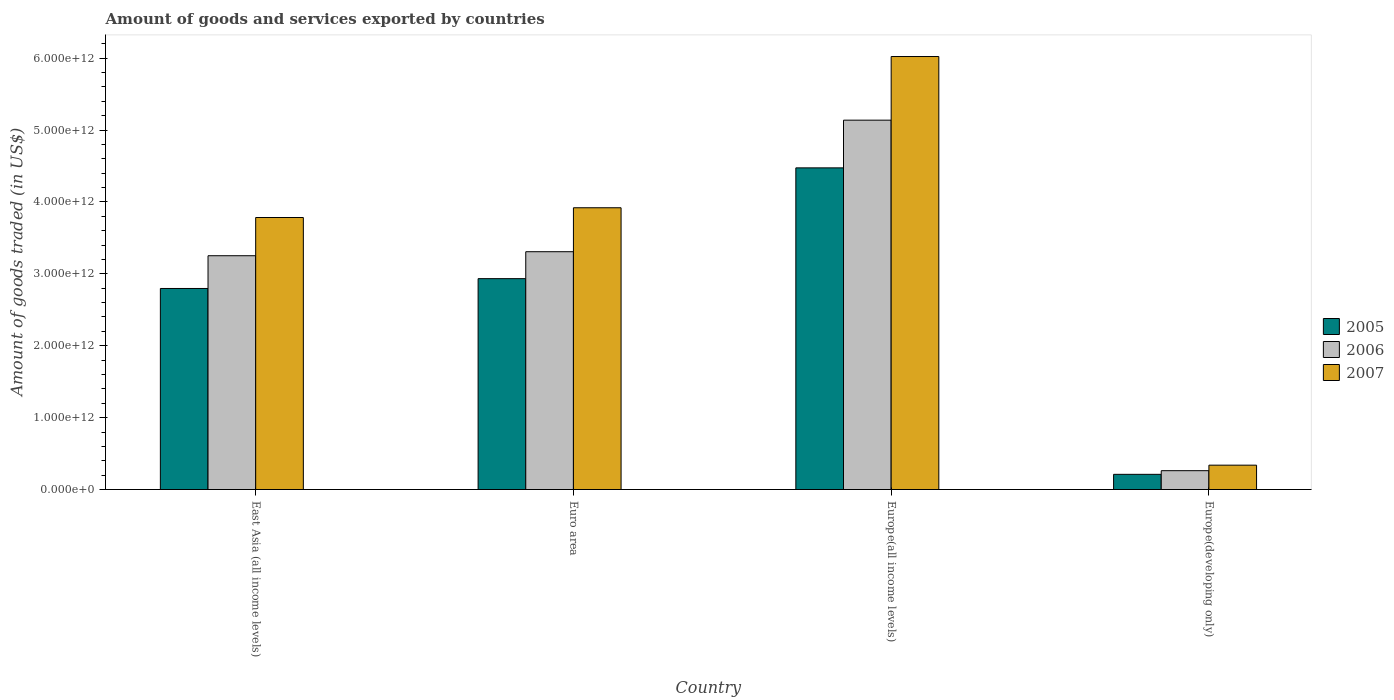How many groups of bars are there?
Your answer should be very brief. 4. How many bars are there on the 1st tick from the left?
Your answer should be compact. 3. How many bars are there on the 3rd tick from the right?
Provide a short and direct response. 3. What is the label of the 3rd group of bars from the left?
Ensure brevity in your answer.  Europe(all income levels). In how many cases, is the number of bars for a given country not equal to the number of legend labels?
Your answer should be very brief. 0. What is the total amount of goods and services exported in 2007 in Europe(developing only)?
Make the answer very short. 3.39e+11. Across all countries, what is the maximum total amount of goods and services exported in 2006?
Give a very brief answer. 5.14e+12. Across all countries, what is the minimum total amount of goods and services exported in 2007?
Offer a terse response. 3.39e+11. In which country was the total amount of goods and services exported in 2006 maximum?
Your answer should be very brief. Europe(all income levels). In which country was the total amount of goods and services exported in 2006 minimum?
Your answer should be very brief. Europe(developing only). What is the total total amount of goods and services exported in 2007 in the graph?
Provide a succinct answer. 1.41e+13. What is the difference between the total amount of goods and services exported in 2006 in Euro area and that in Europe(developing only)?
Keep it short and to the point. 3.05e+12. What is the difference between the total amount of goods and services exported in 2005 in East Asia (all income levels) and the total amount of goods and services exported in 2006 in Europe(all income levels)?
Keep it short and to the point. -2.34e+12. What is the average total amount of goods and services exported in 2005 per country?
Your response must be concise. 2.60e+12. What is the difference between the total amount of goods and services exported of/in 2005 and total amount of goods and services exported of/in 2006 in East Asia (all income levels)?
Give a very brief answer. -4.55e+11. In how many countries, is the total amount of goods and services exported in 2006 greater than 800000000000 US$?
Ensure brevity in your answer.  3. What is the ratio of the total amount of goods and services exported in 2005 in Europe(all income levels) to that in Europe(developing only)?
Offer a very short reply. 21.19. Is the difference between the total amount of goods and services exported in 2005 in Euro area and Europe(all income levels) greater than the difference between the total amount of goods and services exported in 2006 in Euro area and Europe(all income levels)?
Ensure brevity in your answer.  Yes. What is the difference between the highest and the second highest total amount of goods and services exported in 2007?
Your response must be concise. -2.24e+12. What is the difference between the highest and the lowest total amount of goods and services exported in 2007?
Provide a succinct answer. 5.68e+12. In how many countries, is the total amount of goods and services exported in 2005 greater than the average total amount of goods and services exported in 2005 taken over all countries?
Give a very brief answer. 3. Is the sum of the total amount of goods and services exported in 2007 in East Asia (all income levels) and Europe(developing only) greater than the maximum total amount of goods and services exported in 2005 across all countries?
Offer a terse response. No. What does the 2nd bar from the left in Europe(developing only) represents?
Offer a very short reply. 2006. What does the 3rd bar from the right in Europe(all income levels) represents?
Make the answer very short. 2005. Is it the case that in every country, the sum of the total amount of goods and services exported in 2005 and total amount of goods and services exported in 2006 is greater than the total amount of goods and services exported in 2007?
Provide a succinct answer. Yes. How many bars are there?
Offer a very short reply. 12. Are all the bars in the graph horizontal?
Your answer should be very brief. No. How many countries are there in the graph?
Offer a very short reply. 4. What is the difference between two consecutive major ticks on the Y-axis?
Keep it short and to the point. 1.00e+12. Are the values on the major ticks of Y-axis written in scientific E-notation?
Ensure brevity in your answer.  Yes. Does the graph contain grids?
Your answer should be compact. No. Where does the legend appear in the graph?
Your answer should be compact. Center right. How many legend labels are there?
Keep it short and to the point. 3. What is the title of the graph?
Your response must be concise. Amount of goods and services exported by countries. What is the label or title of the X-axis?
Keep it short and to the point. Country. What is the label or title of the Y-axis?
Offer a very short reply. Amount of goods traded (in US$). What is the Amount of goods traded (in US$) in 2005 in East Asia (all income levels)?
Offer a very short reply. 2.80e+12. What is the Amount of goods traded (in US$) of 2006 in East Asia (all income levels)?
Your answer should be very brief. 3.25e+12. What is the Amount of goods traded (in US$) of 2007 in East Asia (all income levels)?
Offer a terse response. 3.78e+12. What is the Amount of goods traded (in US$) in 2005 in Euro area?
Your answer should be very brief. 2.93e+12. What is the Amount of goods traded (in US$) of 2006 in Euro area?
Keep it short and to the point. 3.31e+12. What is the Amount of goods traded (in US$) of 2007 in Euro area?
Offer a terse response. 3.92e+12. What is the Amount of goods traded (in US$) in 2005 in Europe(all income levels)?
Keep it short and to the point. 4.47e+12. What is the Amount of goods traded (in US$) of 2006 in Europe(all income levels)?
Offer a terse response. 5.14e+12. What is the Amount of goods traded (in US$) of 2007 in Europe(all income levels)?
Provide a succinct answer. 6.02e+12. What is the Amount of goods traded (in US$) in 2005 in Europe(developing only)?
Provide a short and direct response. 2.11e+11. What is the Amount of goods traded (in US$) in 2006 in Europe(developing only)?
Provide a short and direct response. 2.62e+11. What is the Amount of goods traded (in US$) of 2007 in Europe(developing only)?
Your answer should be very brief. 3.39e+11. Across all countries, what is the maximum Amount of goods traded (in US$) in 2005?
Make the answer very short. 4.47e+12. Across all countries, what is the maximum Amount of goods traded (in US$) of 2006?
Offer a very short reply. 5.14e+12. Across all countries, what is the maximum Amount of goods traded (in US$) of 2007?
Keep it short and to the point. 6.02e+12. Across all countries, what is the minimum Amount of goods traded (in US$) of 2005?
Offer a very short reply. 2.11e+11. Across all countries, what is the minimum Amount of goods traded (in US$) of 2006?
Give a very brief answer. 2.62e+11. Across all countries, what is the minimum Amount of goods traded (in US$) in 2007?
Give a very brief answer. 3.39e+11. What is the total Amount of goods traded (in US$) of 2005 in the graph?
Keep it short and to the point. 1.04e+13. What is the total Amount of goods traded (in US$) of 2006 in the graph?
Your response must be concise. 1.20e+13. What is the total Amount of goods traded (in US$) of 2007 in the graph?
Ensure brevity in your answer.  1.41e+13. What is the difference between the Amount of goods traded (in US$) of 2005 in East Asia (all income levels) and that in Euro area?
Provide a short and direct response. -1.37e+11. What is the difference between the Amount of goods traded (in US$) of 2006 in East Asia (all income levels) and that in Euro area?
Your response must be concise. -5.60e+1. What is the difference between the Amount of goods traded (in US$) in 2007 in East Asia (all income levels) and that in Euro area?
Offer a terse response. -1.36e+11. What is the difference between the Amount of goods traded (in US$) in 2005 in East Asia (all income levels) and that in Europe(all income levels)?
Your response must be concise. -1.68e+12. What is the difference between the Amount of goods traded (in US$) of 2006 in East Asia (all income levels) and that in Europe(all income levels)?
Offer a terse response. -1.89e+12. What is the difference between the Amount of goods traded (in US$) in 2007 in East Asia (all income levels) and that in Europe(all income levels)?
Keep it short and to the point. -2.24e+12. What is the difference between the Amount of goods traded (in US$) of 2005 in East Asia (all income levels) and that in Europe(developing only)?
Your answer should be compact. 2.59e+12. What is the difference between the Amount of goods traded (in US$) in 2006 in East Asia (all income levels) and that in Europe(developing only)?
Offer a very short reply. 2.99e+12. What is the difference between the Amount of goods traded (in US$) of 2007 in East Asia (all income levels) and that in Europe(developing only)?
Your answer should be very brief. 3.44e+12. What is the difference between the Amount of goods traded (in US$) of 2005 in Euro area and that in Europe(all income levels)?
Keep it short and to the point. -1.54e+12. What is the difference between the Amount of goods traded (in US$) of 2006 in Euro area and that in Europe(all income levels)?
Offer a terse response. -1.83e+12. What is the difference between the Amount of goods traded (in US$) in 2007 in Euro area and that in Europe(all income levels)?
Ensure brevity in your answer.  -2.10e+12. What is the difference between the Amount of goods traded (in US$) in 2005 in Euro area and that in Europe(developing only)?
Your response must be concise. 2.72e+12. What is the difference between the Amount of goods traded (in US$) in 2006 in Euro area and that in Europe(developing only)?
Ensure brevity in your answer.  3.05e+12. What is the difference between the Amount of goods traded (in US$) in 2007 in Euro area and that in Europe(developing only)?
Your answer should be compact. 3.58e+12. What is the difference between the Amount of goods traded (in US$) of 2005 in Europe(all income levels) and that in Europe(developing only)?
Your answer should be compact. 4.26e+12. What is the difference between the Amount of goods traded (in US$) of 2006 in Europe(all income levels) and that in Europe(developing only)?
Make the answer very short. 4.88e+12. What is the difference between the Amount of goods traded (in US$) of 2007 in Europe(all income levels) and that in Europe(developing only)?
Give a very brief answer. 5.68e+12. What is the difference between the Amount of goods traded (in US$) of 2005 in East Asia (all income levels) and the Amount of goods traded (in US$) of 2006 in Euro area?
Provide a succinct answer. -5.11e+11. What is the difference between the Amount of goods traded (in US$) of 2005 in East Asia (all income levels) and the Amount of goods traded (in US$) of 2007 in Euro area?
Provide a succinct answer. -1.12e+12. What is the difference between the Amount of goods traded (in US$) in 2006 in East Asia (all income levels) and the Amount of goods traded (in US$) in 2007 in Euro area?
Your answer should be compact. -6.67e+11. What is the difference between the Amount of goods traded (in US$) in 2005 in East Asia (all income levels) and the Amount of goods traded (in US$) in 2006 in Europe(all income levels)?
Give a very brief answer. -2.34e+12. What is the difference between the Amount of goods traded (in US$) of 2005 in East Asia (all income levels) and the Amount of goods traded (in US$) of 2007 in Europe(all income levels)?
Your answer should be very brief. -3.23e+12. What is the difference between the Amount of goods traded (in US$) of 2006 in East Asia (all income levels) and the Amount of goods traded (in US$) of 2007 in Europe(all income levels)?
Keep it short and to the point. -2.77e+12. What is the difference between the Amount of goods traded (in US$) of 2005 in East Asia (all income levels) and the Amount of goods traded (in US$) of 2006 in Europe(developing only)?
Keep it short and to the point. 2.53e+12. What is the difference between the Amount of goods traded (in US$) of 2005 in East Asia (all income levels) and the Amount of goods traded (in US$) of 2007 in Europe(developing only)?
Provide a succinct answer. 2.46e+12. What is the difference between the Amount of goods traded (in US$) of 2006 in East Asia (all income levels) and the Amount of goods traded (in US$) of 2007 in Europe(developing only)?
Provide a succinct answer. 2.91e+12. What is the difference between the Amount of goods traded (in US$) in 2005 in Euro area and the Amount of goods traded (in US$) in 2006 in Europe(all income levels)?
Provide a succinct answer. -2.20e+12. What is the difference between the Amount of goods traded (in US$) in 2005 in Euro area and the Amount of goods traded (in US$) in 2007 in Europe(all income levels)?
Keep it short and to the point. -3.09e+12. What is the difference between the Amount of goods traded (in US$) in 2006 in Euro area and the Amount of goods traded (in US$) in 2007 in Europe(all income levels)?
Your answer should be very brief. -2.71e+12. What is the difference between the Amount of goods traded (in US$) of 2005 in Euro area and the Amount of goods traded (in US$) of 2006 in Europe(developing only)?
Keep it short and to the point. 2.67e+12. What is the difference between the Amount of goods traded (in US$) of 2005 in Euro area and the Amount of goods traded (in US$) of 2007 in Europe(developing only)?
Ensure brevity in your answer.  2.59e+12. What is the difference between the Amount of goods traded (in US$) in 2006 in Euro area and the Amount of goods traded (in US$) in 2007 in Europe(developing only)?
Give a very brief answer. 2.97e+12. What is the difference between the Amount of goods traded (in US$) in 2005 in Europe(all income levels) and the Amount of goods traded (in US$) in 2006 in Europe(developing only)?
Offer a very short reply. 4.21e+12. What is the difference between the Amount of goods traded (in US$) in 2005 in Europe(all income levels) and the Amount of goods traded (in US$) in 2007 in Europe(developing only)?
Provide a short and direct response. 4.14e+12. What is the difference between the Amount of goods traded (in US$) of 2006 in Europe(all income levels) and the Amount of goods traded (in US$) of 2007 in Europe(developing only)?
Your answer should be very brief. 4.80e+12. What is the average Amount of goods traded (in US$) of 2005 per country?
Provide a short and direct response. 2.60e+12. What is the average Amount of goods traded (in US$) of 2006 per country?
Your answer should be compact. 2.99e+12. What is the average Amount of goods traded (in US$) in 2007 per country?
Keep it short and to the point. 3.52e+12. What is the difference between the Amount of goods traded (in US$) in 2005 and Amount of goods traded (in US$) in 2006 in East Asia (all income levels)?
Provide a short and direct response. -4.55e+11. What is the difference between the Amount of goods traded (in US$) in 2005 and Amount of goods traded (in US$) in 2007 in East Asia (all income levels)?
Your answer should be very brief. -9.87e+11. What is the difference between the Amount of goods traded (in US$) of 2006 and Amount of goods traded (in US$) of 2007 in East Asia (all income levels)?
Make the answer very short. -5.32e+11. What is the difference between the Amount of goods traded (in US$) of 2005 and Amount of goods traded (in US$) of 2006 in Euro area?
Keep it short and to the point. -3.75e+11. What is the difference between the Amount of goods traded (in US$) in 2005 and Amount of goods traded (in US$) in 2007 in Euro area?
Provide a short and direct response. -9.86e+11. What is the difference between the Amount of goods traded (in US$) in 2006 and Amount of goods traded (in US$) in 2007 in Euro area?
Keep it short and to the point. -6.11e+11. What is the difference between the Amount of goods traded (in US$) of 2005 and Amount of goods traded (in US$) of 2006 in Europe(all income levels)?
Your answer should be compact. -6.64e+11. What is the difference between the Amount of goods traded (in US$) in 2005 and Amount of goods traded (in US$) in 2007 in Europe(all income levels)?
Give a very brief answer. -1.55e+12. What is the difference between the Amount of goods traded (in US$) in 2006 and Amount of goods traded (in US$) in 2007 in Europe(all income levels)?
Make the answer very short. -8.85e+11. What is the difference between the Amount of goods traded (in US$) in 2005 and Amount of goods traded (in US$) in 2006 in Europe(developing only)?
Your response must be concise. -5.09e+1. What is the difference between the Amount of goods traded (in US$) in 2005 and Amount of goods traded (in US$) in 2007 in Europe(developing only)?
Offer a very short reply. -1.28e+11. What is the difference between the Amount of goods traded (in US$) in 2006 and Amount of goods traded (in US$) in 2007 in Europe(developing only)?
Your response must be concise. -7.67e+1. What is the ratio of the Amount of goods traded (in US$) in 2005 in East Asia (all income levels) to that in Euro area?
Ensure brevity in your answer.  0.95. What is the ratio of the Amount of goods traded (in US$) in 2006 in East Asia (all income levels) to that in Euro area?
Provide a short and direct response. 0.98. What is the ratio of the Amount of goods traded (in US$) in 2007 in East Asia (all income levels) to that in Euro area?
Your answer should be compact. 0.97. What is the ratio of the Amount of goods traded (in US$) of 2005 in East Asia (all income levels) to that in Europe(all income levels)?
Your answer should be very brief. 0.62. What is the ratio of the Amount of goods traded (in US$) of 2006 in East Asia (all income levels) to that in Europe(all income levels)?
Provide a succinct answer. 0.63. What is the ratio of the Amount of goods traded (in US$) in 2007 in East Asia (all income levels) to that in Europe(all income levels)?
Provide a short and direct response. 0.63. What is the ratio of the Amount of goods traded (in US$) of 2005 in East Asia (all income levels) to that in Europe(developing only)?
Give a very brief answer. 13.24. What is the ratio of the Amount of goods traded (in US$) in 2006 in East Asia (all income levels) to that in Europe(developing only)?
Offer a very short reply. 12.41. What is the ratio of the Amount of goods traded (in US$) in 2007 in East Asia (all income levels) to that in Europe(developing only)?
Give a very brief answer. 11.17. What is the ratio of the Amount of goods traded (in US$) of 2005 in Euro area to that in Europe(all income levels)?
Keep it short and to the point. 0.66. What is the ratio of the Amount of goods traded (in US$) of 2006 in Euro area to that in Europe(all income levels)?
Give a very brief answer. 0.64. What is the ratio of the Amount of goods traded (in US$) of 2007 in Euro area to that in Europe(all income levels)?
Your answer should be compact. 0.65. What is the ratio of the Amount of goods traded (in US$) of 2005 in Euro area to that in Europe(developing only)?
Offer a terse response. 13.89. What is the ratio of the Amount of goods traded (in US$) of 2006 in Euro area to that in Europe(developing only)?
Your answer should be very brief. 12.62. What is the ratio of the Amount of goods traded (in US$) in 2007 in Euro area to that in Europe(developing only)?
Offer a terse response. 11.57. What is the ratio of the Amount of goods traded (in US$) of 2005 in Europe(all income levels) to that in Europe(developing only)?
Offer a terse response. 21.19. What is the ratio of the Amount of goods traded (in US$) in 2006 in Europe(all income levels) to that in Europe(developing only)?
Your answer should be compact. 19.61. What is the ratio of the Amount of goods traded (in US$) of 2007 in Europe(all income levels) to that in Europe(developing only)?
Your response must be concise. 17.78. What is the difference between the highest and the second highest Amount of goods traded (in US$) of 2005?
Your answer should be very brief. 1.54e+12. What is the difference between the highest and the second highest Amount of goods traded (in US$) in 2006?
Your answer should be compact. 1.83e+12. What is the difference between the highest and the second highest Amount of goods traded (in US$) of 2007?
Your response must be concise. 2.10e+12. What is the difference between the highest and the lowest Amount of goods traded (in US$) in 2005?
Your answer should be compact. 4.26e+12. What is the difference between the highest and the lowest Amount of goods traded (in US$) of 2006?
Your response must be concise. 4.88e+12. What is the difference between the highest and the lowest Amount of goods traded (in US$) of 2007?
Your answer should be compact. 5.68e+12. 